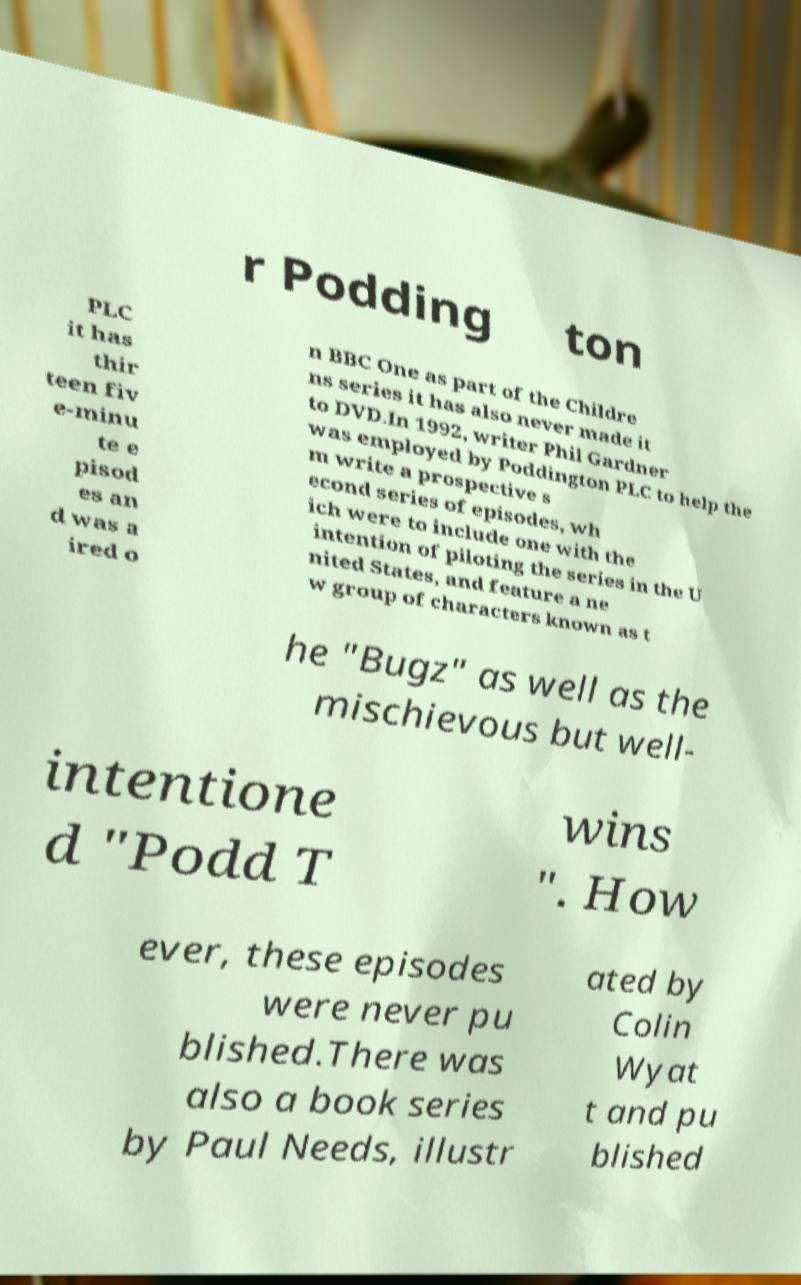For documentation purposes, I need the text within this image transcribed. Could you provide that? r Podding ton PLC it has thir teen fiv e-minu te e pisod es an d was a ired o n BBC One as part of the Childre ns series it has also never made it to DVD.In 1992, writer Phil Gardner was employed by Poddington PLC to help the m write a prospective s econd series of episodes, wh ich were to include one with the intention of piloting the series in the U nited States, and feature a ne w group of characters known as t he "Bugz" as well as the mischievous but well- intentione d "Podd T wins ". How ever, these episodes were never pu blished.There was also a book series by Paul Needs, illustr ated by Colin Wyat t and pu blished 